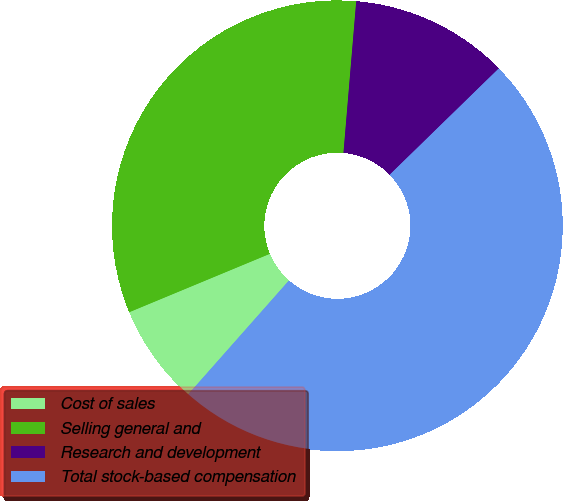Convert chart to OTSL. <chart><loc_0><loc_0><loc_500><loc_500><pie_chart><fcel>Cost of sales<fcel>Selling general and<fcel>Research and development<fcel>Total stock-based compensation<nl><fcel>7.21%<fcel>32.6%<fcel>11.37%<fcel>48.82%<nl></chart> 